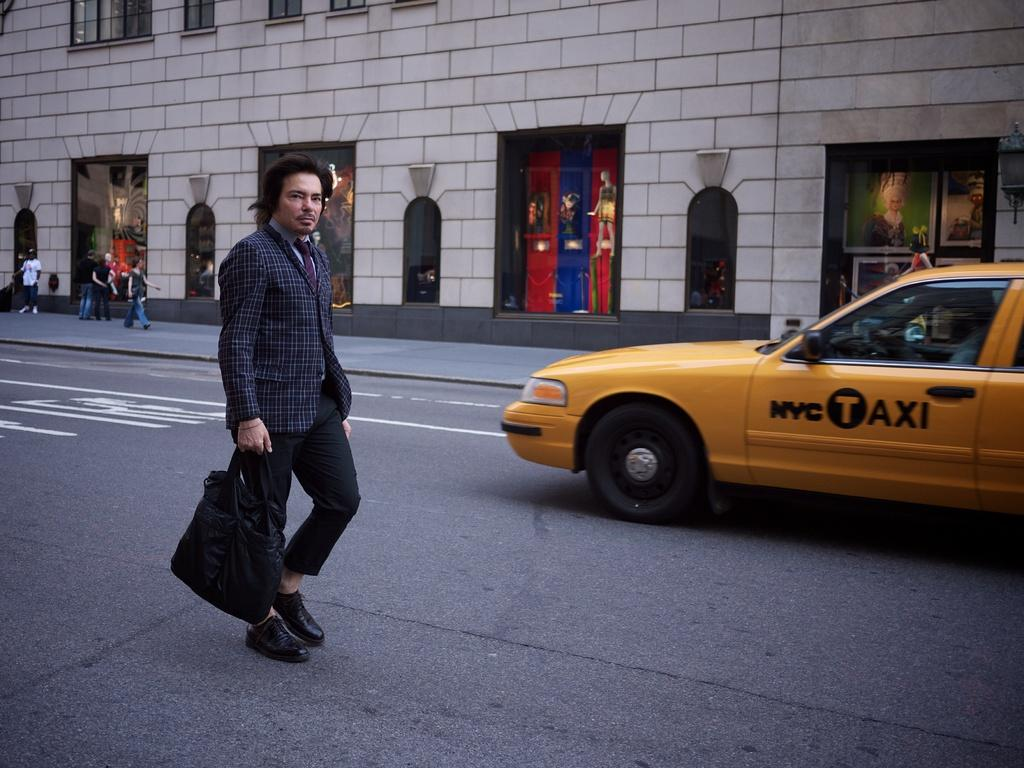<image>
Provide a brief description of the given image. A man in a plaid jacket is walking near a NYC Taxi. 